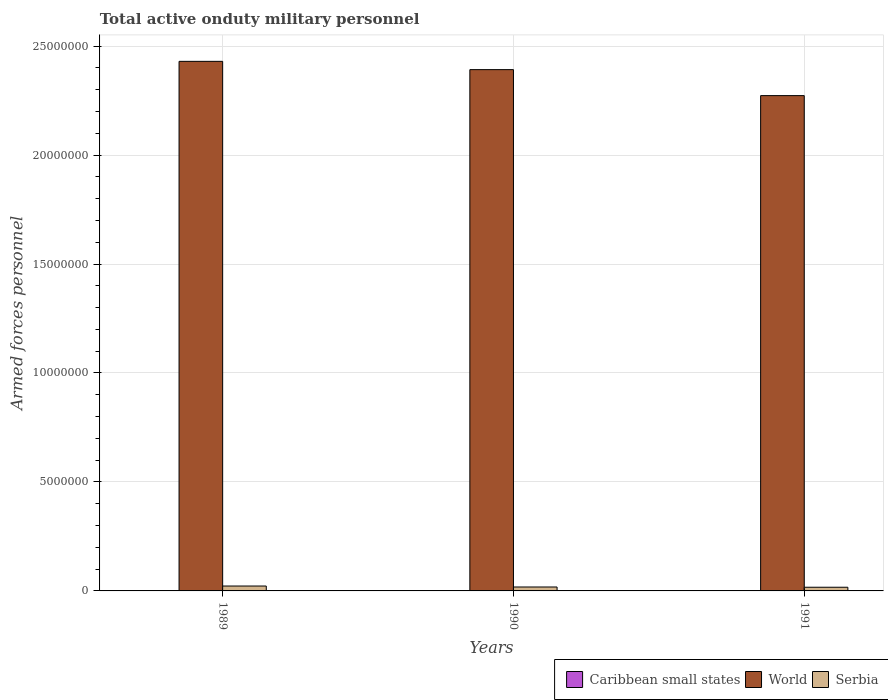How many bars are there on the 1st tick from the left?
Ensure brevity in your answer.  3. What is the label of the 1st group of bars from the left?
Offer a very short reply. 1989. What is the number of armed forces personnel in Serbia in 1991?
Your answer should be very brief. 1.69e+05. Across all years, what is the maximum number of armed forces personnel in Caribbean small states?
Provide a succinct answer. 1.40e+04. Across all years, what is the minimum number of armed forces personnel in Caribbean small states?
Give a very brief answer. 1.40e+04. In which year was the number of armed forces personnel in Caribbean small states minimum?
Offer a terse response. 1989. What is the total number of armed forces personnel in Serbia in the graph?
Ensure brevity in your answer.  5.74e+05. What is the difference between the number of armed forces personnel in Caribbean small states in 1989 and that in 1991?
Provide a succinct answer. 0. What is the difference between the number of armed forces personnel in Serbia in 1991 and the number of armed forces personnel in World in 1990?
Make the answer very short. -2.37e+07. What is the average number of armed forces personnel in Caribbean small states per year?
Give a very brief answer. 1.40e+04. In the year 1989, what is the difference between the number of armed forces personnel in Caribbean small states and number of armed forces personnel in World?
Ensure brevity in your answer.  -2.43e+07. What is the ratio of the number of armed forces personnel in World in 1989 to that in 1990?
Your answer should be compact. 1.02. Is the number of armed forces personnel in Serbia in 1990 less than that in 1991?
Ensure brevity in your answer.  No. What is the difference between the highest and the lowest number of armed forces personnel in Serbia?
Offer a terse response. 5.60e+04. What does the 3rd bar from the left in 1990 represents?
Your answer should be compact. Serbia. What does the 3rd bar from the right in 1990 represents?
Keep it short and to the point. Caribbean small states. Are all the bars in the graph horizontal?
Provide a succinct answer. No. How many years are there in the graph?
Your answer should be compact. 3. Are the values on the major ticks of Y-axis written in scientific E-notation?
Give a very brief answer. No. What is the title of the graph?
Your answer should be compact. Total active onduty military personnel. What is the label or title of the Y-axis?
Offer a terse response. Armed forces personnel. What is the Armed forces personnel of Caribbean small states in 1989?
Your answer should be very brief. 1.40e+04. What is the Armed forces personnel of World in 1989?
Give a very brief answer. 2.43e+07. What is the Armed forces personnel of Serbia in 1989?
Provide a succinct answer. 2.25e+05. What is the Armed forces personnel in Caribbean small states in 1990?
Your answer should be very brief. 1.40e+04. What is the Armed forces personnel in World in 1990?
Ensure brevity in your answer.  2.39e+07. What is the Armed forces personnel in Serbia in 1990?
Make the answer very short. 1.80e+05. What is the Armed forces personnel in Caribbean small states in 1991?
Offer a terse response. 1.40e+04. What is the Armed forces personnel of World in 1991?
Keep it short and to the point. 2.27e+07. What is the Armed forces personnel of Serbia in 1991?
Your answer should be very brief. 1.69e+05. Across all years, what is the maximum Armed forces personnel of Caribbean small states?
Offer a very short reply. 1.40e+04. Across all years, what is the maximum Armed forces personnel of World?
Ensure brevity in your answer.  2.43e+07. Across all years, what is the maximum Armed forces personnel in Serbia?
Your answer should be very brief. 2.25e+05. Across all years, what is the minimum Armed forces personnel in Caribbean small states?
Ensure brevity in your answer.  1.40e+04. Across all years, what is the minimum Armed forces personnel of World?
Give a very brief answer. 2.27e+07. Across all years, what is the minimum Armed forces personnel in Serbia?
Make the answer very short. 1.69e+05. What is the total Armed forces personnel in Caribbean small states in the graph?
Your answer should be compact. 4.20e+04. What is the total Armed forces personnel in World in the graph?
Your answer should be compact. 7.09e+07. What is the total Armed forces personnel in Serbia in the graph?
Provide a succinct answer. 5.74e+05. What is the difference between the Armed forces personnel of Caribbean small states in 1989 and that in 1990?
Your response must be concise. 0. What is the difference between the Armed forces personnel of Serbia in 1989 and that in 1990?
Offer a very short reply. 4.50e+04. What is the difference between the Armed forces personnel in World in 1989 and that in 1991?
Keep it short and to the point. 1.57e+06. What is the difference between the Armed forces personnel of Serbia in 1989 and that in 1991?
Your answer should be compact. 5.60e+04. What is the difference between the Armed forces personnel of World in 1990 and that in 1991?
Make the answer very short. 1.19e+06. What is the difference between the Armed forces personnel in Serbia in 1990 and that in 1991?
Offer a very short reply. 1.10e+04. What is the difference between the Armed forces personnel in Caribbean small states in 1989 and the Armed forces personnel in World in 1990?
Make the answer very short. -2.39e+07. What is the difference between the Armed forces personnel of Caribbean small states in 1989 and the Armed forces personnel of Serbia in 1990?
Offer a very short reply. -1.66e+05. What is the difference between the Armed forces personnel in World in 1989 and the Armed forces personnel in Serbia in 1990?
Offer a terse response. 2.41e+07. What is the difference between the Armed forces personnel of Caribbean small states in 1989 and the Armed forces personnel of World in 1991?
Ensure brevity in your answer.  -2.27e+07. What is the difference between the Armed forces personnel in Caribbean small states in 1989 and the Armed forces personnel in Serbia in 1991?
Your response must be concise. -1.55e+05. What is the difference between the Armed forces personnel in World in 1989 and the Armed forces personnel in Serbia in 1991?
Your response must be concise. 2.41e+07. What is the difference between the Armed forces personnel in Caribbean small states in 1990 and the Armed forces personnel in World in 1991?
Give a very brief answer. -2.27e+07. What is the difference between the Armed forces personnel in Caribbean small states in 1990 and the Armed forces personnel in Serbia in 1991?
Offer a terse response. -1.55e+05. What is the difference between the Armed forces personnel of World in 1990 and the Armed forces personnel of Serbia in 1991?
Ensure brevity in your answer.  2.37e+07. What is the average Armed forces personnel in Caribbean small states per year?
Keep it short and to the point. 1.40e+04. What is the average Armed forces personnel of World per year?
Offer a very short reply. 2.36e+07. What is the average Armed forces personnel in Serbia per year?
Provide a succinct answer. 1.91e+05. In the year 1989, what is the difference between the Armed forces personnel of Caribbean small states and Armed forces personnel of World?
Provide a short and direct response. -2.43e+07. In the year 1989, what is the difference between the Armed forces personnel of Caribbean small states and Armed forces personnel of Serbia?
Offer a terse response. -2.11e+05. In the year 1989, what is the difference between the Armed forces personnel of World and Armed forces personnel of Serbia?
Make the answer very short. 2.41e+07. In the year 1990, what is the difference between the Armed forces personnel in Caribbean small states and Armed forces personnel in World?
Ensure brevity in your answer.  -2.39e+07. In the year 1990, what is the difference between the Armed forces personnel in Caribbean small states and Armed forces personnel in Serbia?
Offer a very short reply. -1.66e+05. In the year 1990, what is the difference between the Armed forces personnel of World and Armed forces personnel of Serbia?
Keep it short and to the point. 2.37e+07. In the year 1991, what is the difference between the Armed forces personnel of Caribbean small states and Armed forces personnel of World?
Your answer should be compact. -2.27e+07. In the year 1991, what is the difference between the Armed forces personnel of Caribbean small states and Armed forces personnel of Serbia?
Offer a very short reply. -1.55e+05. In the year 1991, what is the difference between the Armed forces personnel in World and Armed forces personnel in Serbia?
Your response must be concise. 2.26e+07. What is the ratio of the Armed forces personnel in Caribbean small states in 1989 to that in 1990?
Offer a very short reply. 1. What is the ratio of the Armed forces personnel in World in 1989 to that in 1990?
Your response must be concise. 1.02. What is the ratio of the Armed forces personnel of World in 1989 to that in 1991?
Offer a very short reply. 1.07. What is the ratio of the Armed forces personnel in Serbia in 1989 to that in 1991?
Offer a very short reply. 1.33. What is the ratio of the Armed forces personnel of Caribbean small states in 1990 to that in 1991?
Your answer should be very brief. 1. What is the ratio of the Armed forces personnel of World in 1990 to that in 1991?
Offer a very short reply. 1.05. What is the ratio of the Armed forces personnel in Serbia in 1990 to that in 1991?
Offer a terse response. 1.07. What is the difference between the highest and the second highest Armed forces personnel in Caribbean small states?
Offer a very short reply. 0. What is the difference between the highest and the second highest Armed forces personnel of Serbia?
Ensure brevity in your answer.  4.50e+04. What is the difference between the highest and the lowest Armed forces personnel in World?
Keep it short and to the point. 1.57e+06. What is the difference between the highest and the lowest Armed forces personnel in Serbia?
Provide a short and direct response. 5.60e+04. 